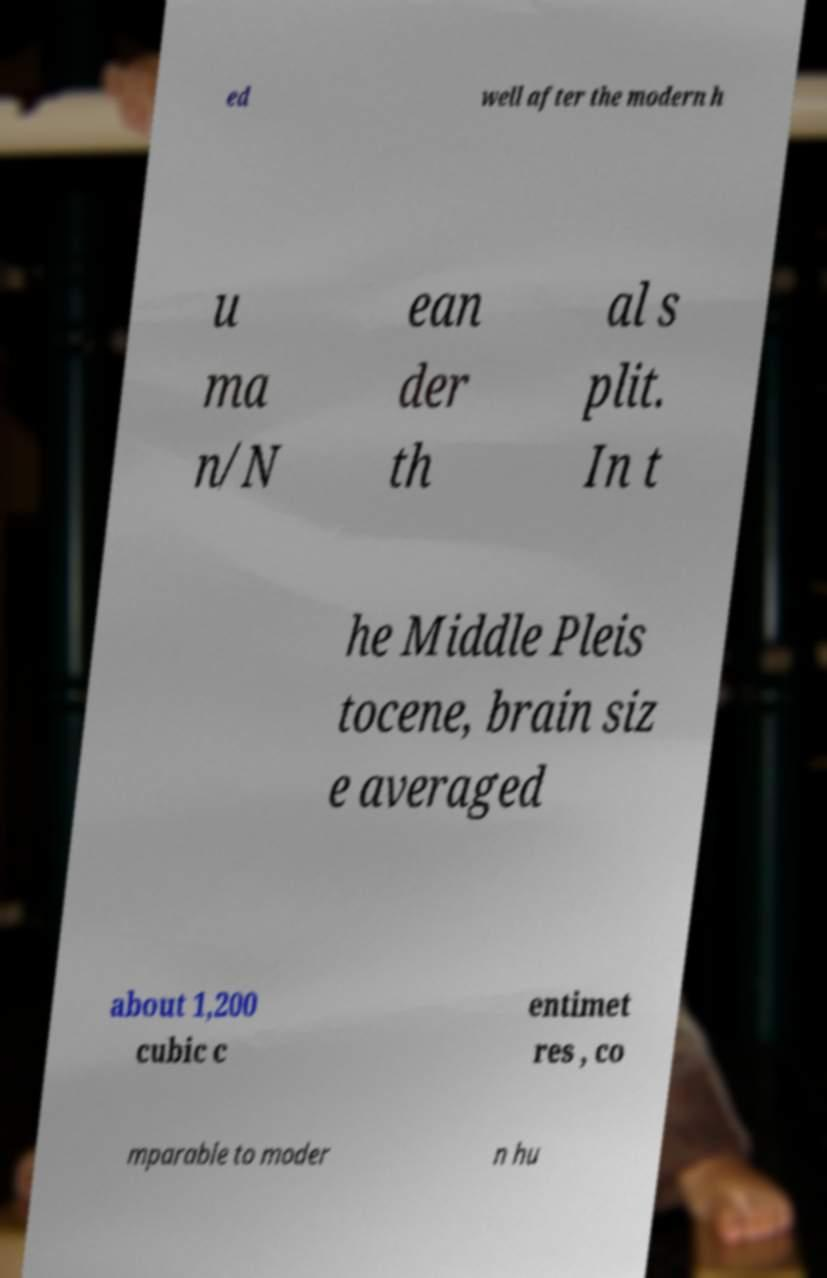Please read and relay the text visible in this image. What does it say? ed well after the modern h u ma n/N ean der th al s plit. In t he Middle Pleis tocene, brain siz e averaged about 1,200 cubic c entimet res , co mparable to moder n hu 